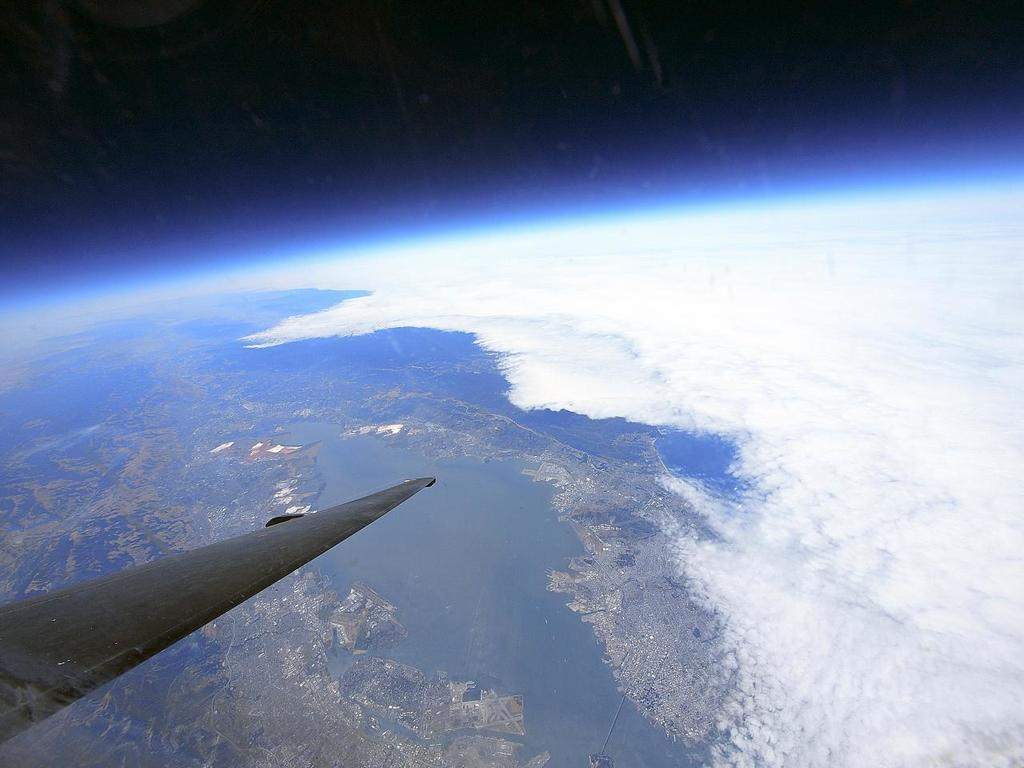Where are the plane's wings located in the image? The plane's wings are visible in the bottom left corner of the image. What is the plane doing in the image? The plane is flying in the sky. What can be seen in the background of the image? There is water, a city, clouds, and trees visible in the background of the image. What part of the natural environment is visible in the image? The sky is visible at the top of the image. What type of mint is growing near the water in the image? There is no mint visible in the image; only water, a city, clouds, and trees can be seen in the background. 